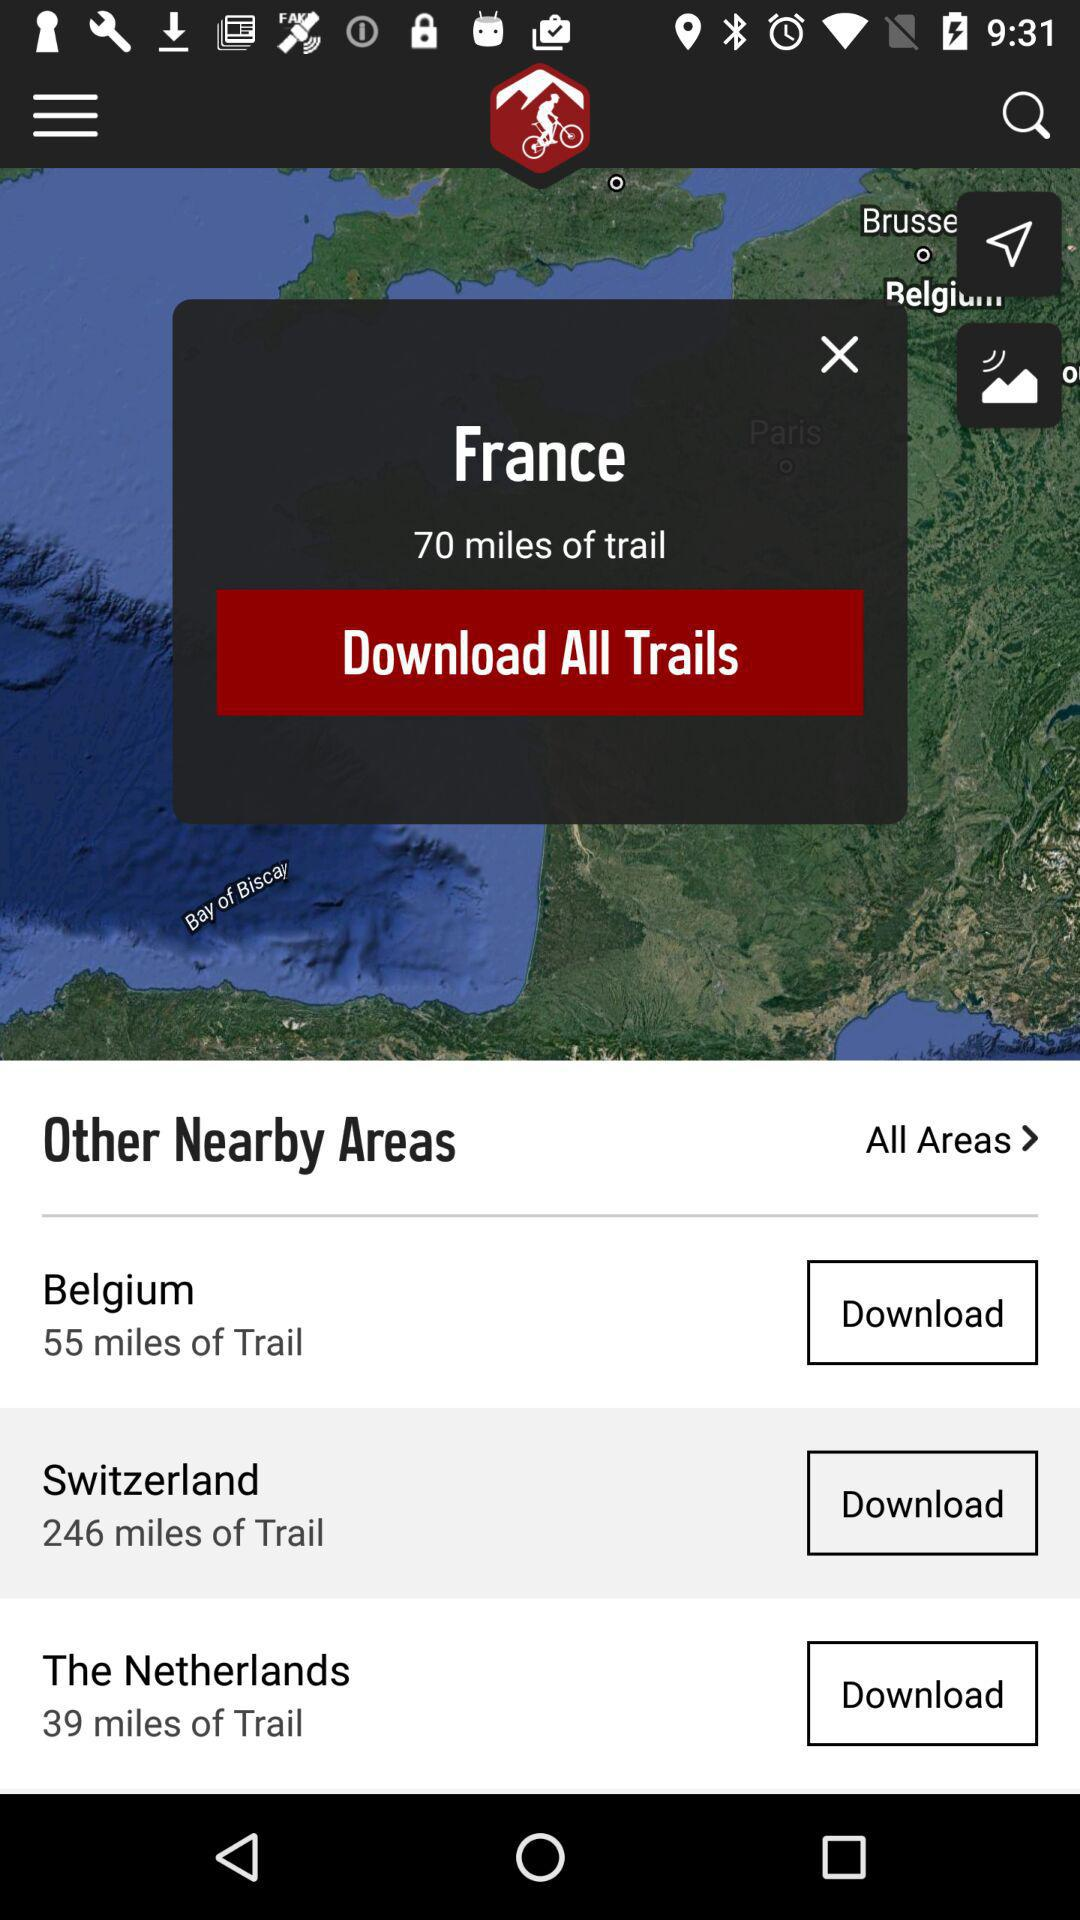How many miles of trail are in Switzerland and The Netherlands combined?
Answer the question using a single word or phrase. 285 